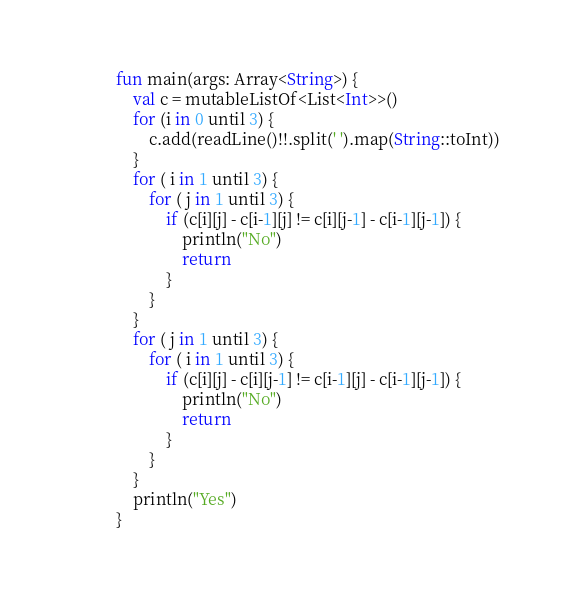<code> <loc_0><loc_0><loc_500><loc_500><_Kotlin_>fun main(args: Array<String>) {
    val c = mutableListOf<List<Int>>()
    for (i in 0 until 3) {
        c.add(readLine()!!.split(' ').map(String::toInt))
    }
    for ( i in 1 until 3) {
        for ( j in 1 until 3) {
            if (c[i][j] - c[i-1][j] != c[i][j-1] - c[i-1][j-1]) {
                println("No")
                return
            }
        }
    }
    for ( j in 1 until 3) {
        for ( i in 1 until 3) {
            if (c[i][j] - c[i][j-1] != c[i-1][j] - c[i-1][j-1]) {
                println("No")
                return
            }
        }
    }
    println("Yes")
}</code> 